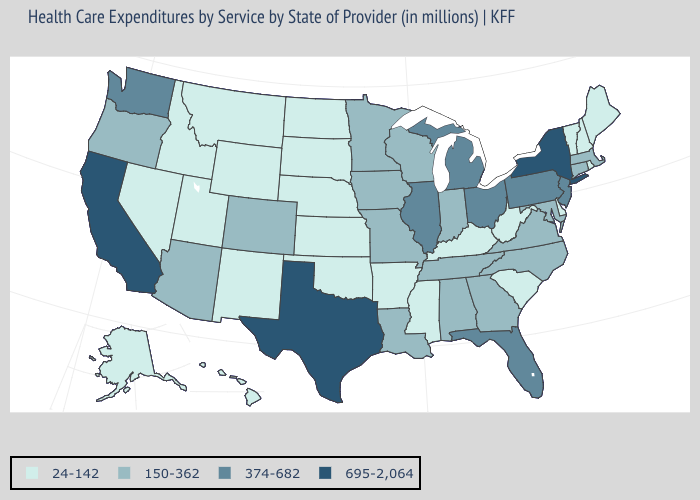What is the highest value in the West ?
Write a very short answer. 695-2,064. Does North Carolina have a lower value than Georgia?
Concise answer only. No. How many symbols are there in the legend?
Short answer required. 4. What is the highest value in the Northeast ?
Concise answer only. 695-2,064. What is the value of Utah?
Answer briefly. 24-142. What is the value of Oklahoma?
Short answer required. 24-142. What is the value of Alabama?
Quick response, please. 150-362. What is the value of Indiana?
Answer briefly. 150-362. Which states hav the highest value in the Northeast?
Give a very brief answer. New York. Name the states that have a value in the range 374-682?
Give a very brief answer. Florida, Illinois, Michigan, New Jersey, Ohio, Pennsylvania, Washington. Name the states that have a value in the range 150-362?
Answer briefly. Alabama, Arizona, Colorado, Connecticut, Georgia, Indiana, Iowa, Louisiana, Maryland, Massachusetts, Minnesota, Missouri, North Carolina, Oregon, Tennessee, Virginia, Wisconsin. Does New York have the highest value in the Northeast?
Keep it brief. Yes. Which states have the lowest value in the MidWest?
Quick response, please. Kansas, Nebraska, North Dakota, South Dakota. What is the value of Maine?
Short answer required. 24-142. 